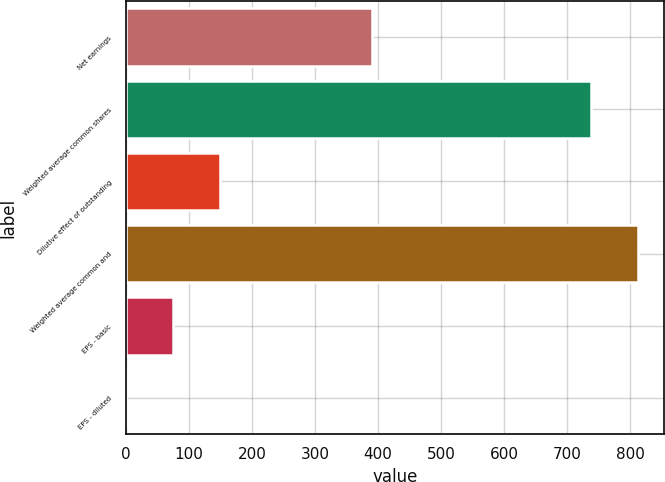Convert chart to OTSL. <chart><loc_0><loc_0><loc_500><loc_500><bar_chart><fcel>Net earnings<fcel>Weighted average common shares<fcel>Dilutive effect of outstanding<fcel>Weighted average common and<fcel>EPS - basic<fcel>EPS - diluted<nl><fcel>390.8<fcel>738.7<fcel>149.6<fcel>813.24<fcel>75.06<fcel>0.52<nl></chart> 